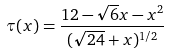Convert formula to latex. <formula><loc_0><loc_0><loc_500><loc_500>\tau ( x ) = \frac { 1 2 - \sqrt { 6 } x - x ^ { 2 } } { ( \sqrt { 2 4 } + x ) ^ { 1 / 2 } }</formula> 